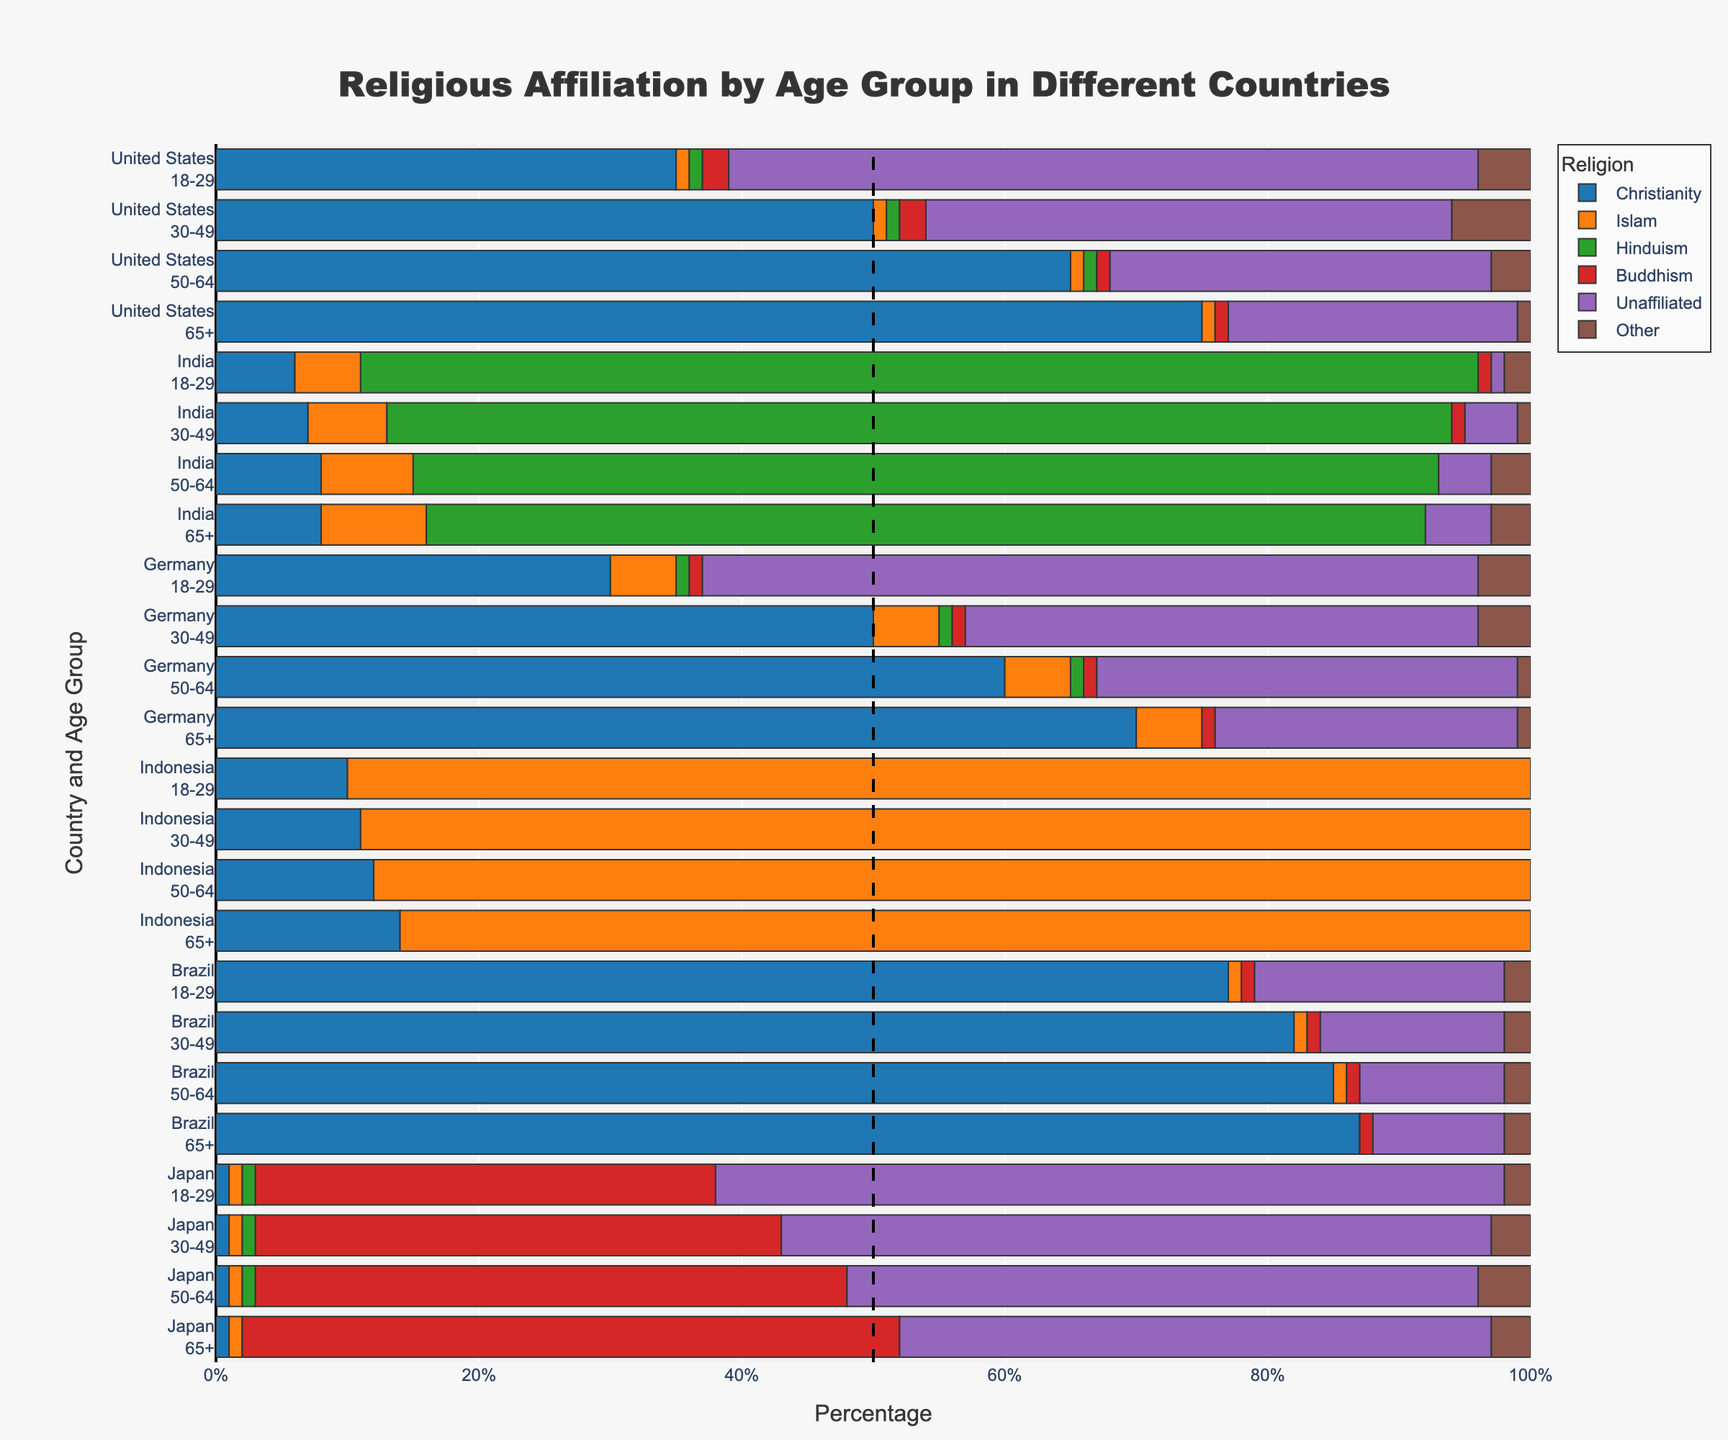Which age group in the United States has the highest proportion of people identifying as Unaffiliated? To determine this, we look at the Unaffiliated sections of the bars for each age group in the United States. We see that the 18-29 age group has the largest Unaffiliated section at 57%.
Answer: 18-29 Which country shows the least variation in religious affiliation across all age groups? To answer this, we need to examine the proportions of each religion across the different age groups in each country. Indonesia shows the least variation, with Islam consistently comprising around 86-90% in all age groups.
Answer: Indonesia How does the proportion of Christians in Brazil change as age increases? We can observe that in Brazil, the proportion of Christians increases with age. Specifically, it goes from 77% in the 18-29 group, to 82% in the 30-49 group, 85% in the 50-64 group, and finally 87% in the 65+ group.
Answer: Increases Compare the proportion of Buddhism in Japan and the United States for the 65+ age group. Which country has a higher percentage? For the 65+ age group, we examine the height of the Buddhism sections in both countries' bars. Japan has 50% while the United States has 1%, indicating Japan has a much higher percentage.
Answer: Japan In which country and age group does Christianity dominate the most? We need to identify which country and age group has the highest percentage of Christianity. Looking at all countries, the United States in the 65+ age group shows the highest at 75%.
Answer: United States, 65+ Which religion is the least represented in India across all age groups, and what is the average percentage of this religion across those age groups? Observing all age groups, Buddhism is consistently the least represented religion in India. Its percentages are 1%, 1%, 0%, and 0%. The average percentage is (1 + 1 + 0 + 0) / 4 = 0.5%.
Answer: Buddhism, 0.5% What is the total percentage of people identifying as religions other than Christianity and Unaffiliated in the United States for the 50-64 age group? We sum up the percentages of all religions other than Christianity and Unaffiliated for the United States in the 50-64 age group: 1% (Islam) + 1% (Hinduism) + 1% (Buddhism) + 3% (Other) = 6%.
Answer: 6% Which age group in Germany has the smallest proportion of Islam followers, and what is that percentage? By looking at the bar sections corresponding to Islam in Germany for all age groups, the 65+ age group has the smallest proportion at 5%.
Answer: 65+, 5% Compare the change in percentage of Unaffiliated from the 18-29 age group to the 65+ age group in Japan. How significant is the change? In Japan, the Unaffiliated percentage in the 18-29 age group is 60%, while it decreases to 45% in the 65+ age group. The change is 60% - 45% = 15%.
Answer: 15% 